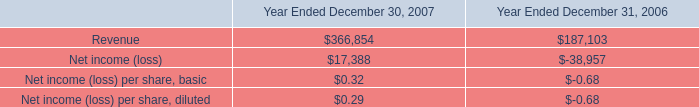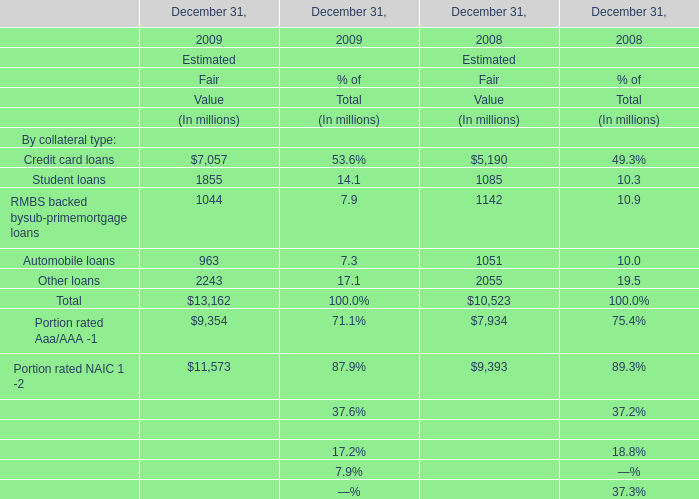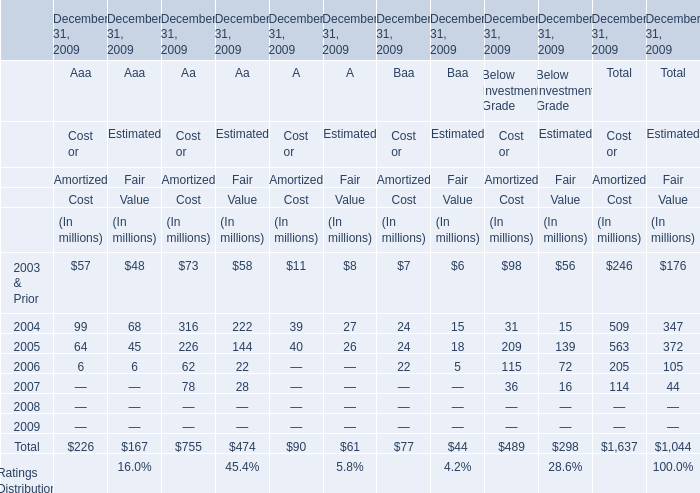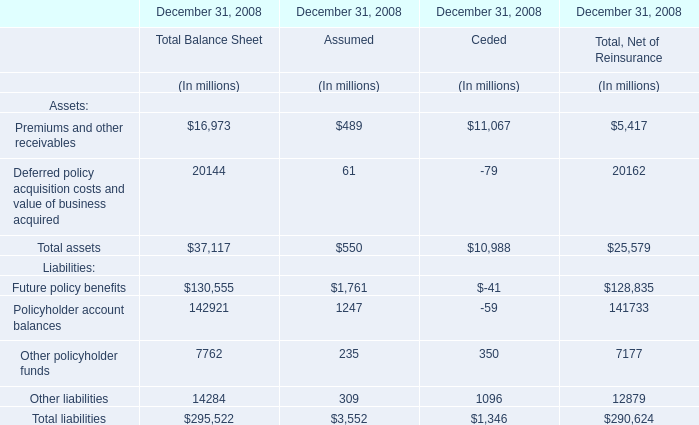What's the growth rate of Cost or Amortized Cost for Aaa in 2005? 
Computations: ((64 - 99) / 99)
Answer: -0.35354. 